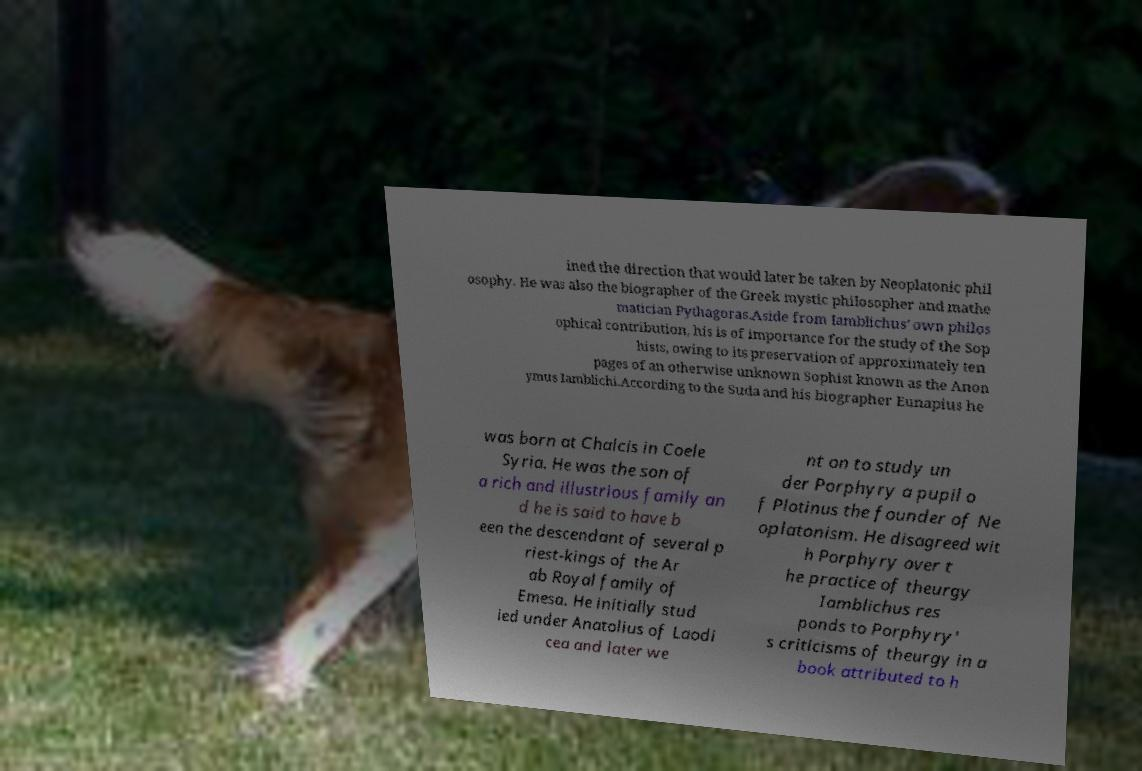Please identify and transcribe the text found in this image. ined the direction that would later be taken by Neoplatonic phil osophy. He was also the biographer of the Greek mystic philosopher and mathe matician Pythagoras.Aside from Iamblichus' own philos ophical contribution, his is of importance for the study of the Sop hists, owing to its preservation of approximately ten pages of an otherwise unknown Sophist known as the Anon ymus Iamblichi.According to the Suda and his biographer Eunapius he was born at Chalcis in Coele Syria. He was the son of a rich and illustrious family an d he is said to have b een the descendant of several p riest-kings of the Ar ab Royal family of Emesa. He initially stud ied under Anatolius of Laodi cea and later we nt on to study un der Porphyry a pupil o f Plotinus the founder of Ne oplatonism. He disagreed wit h Porphyry over t he practice of theurgy Iamblichus res ponds to Porphyry' s criticisms of theurgy in a book attributed to h 